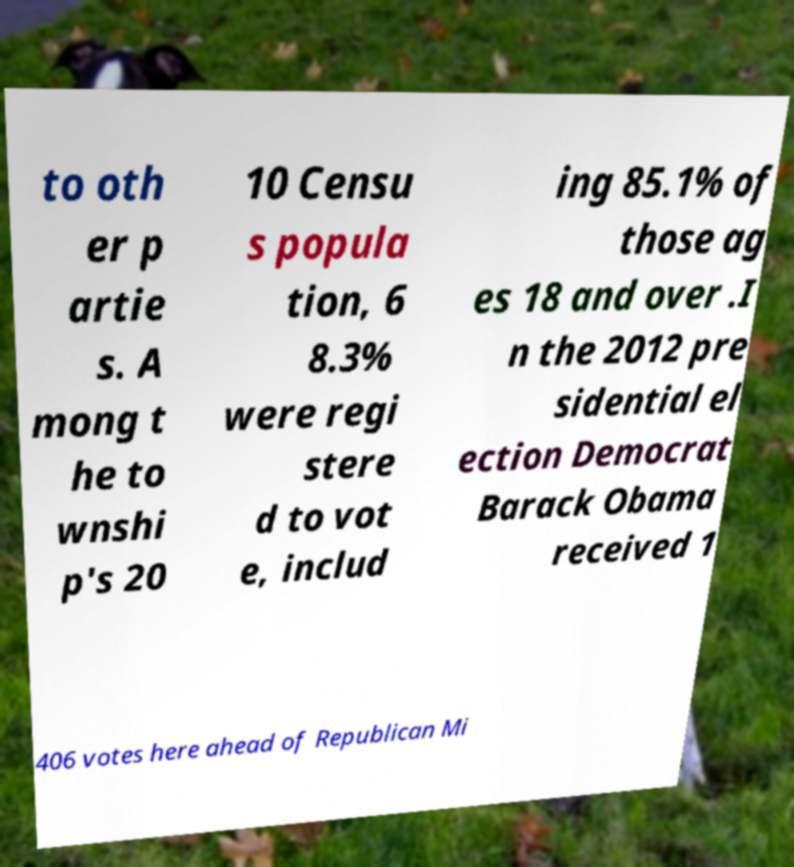I need the written content from this picture converted into text. Can you do that? to oth er p artie s. A mong t he to wnshi p's 20 10 Censu s popula tion, 6 8.3% were regi stere d to vot e, includ ing 85.1% of those ag es 18 and over .I n the 2012 pre sidential el ection Democrat Barack Obama received 1 406 votes here ahead of Republican Mi 